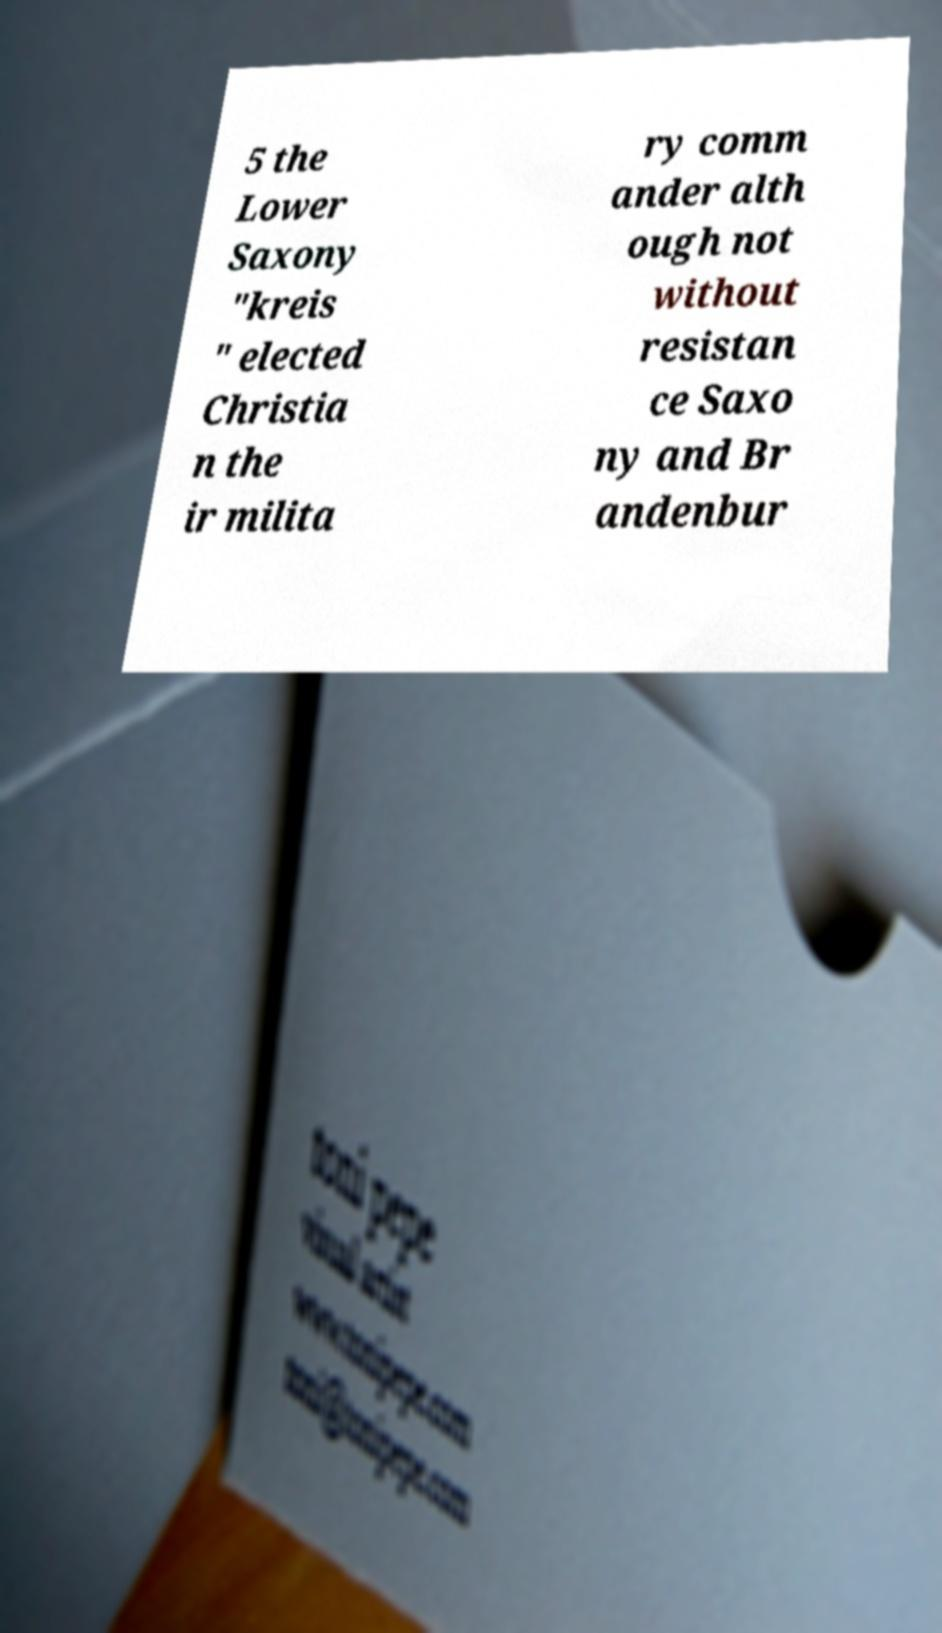Can you accurately transcribe the text from the provided image for me? 5 the Lower Saxony "kreis " elected Christia n the ir milita ry comm ander alth ough not without resistan ce Saxo ny and Br andenbur 